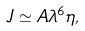<formula> <loc_0><loc_0><loc_500><loc_500>J \simeq A \lambda ^ { 6 } \eta ,</formula> 